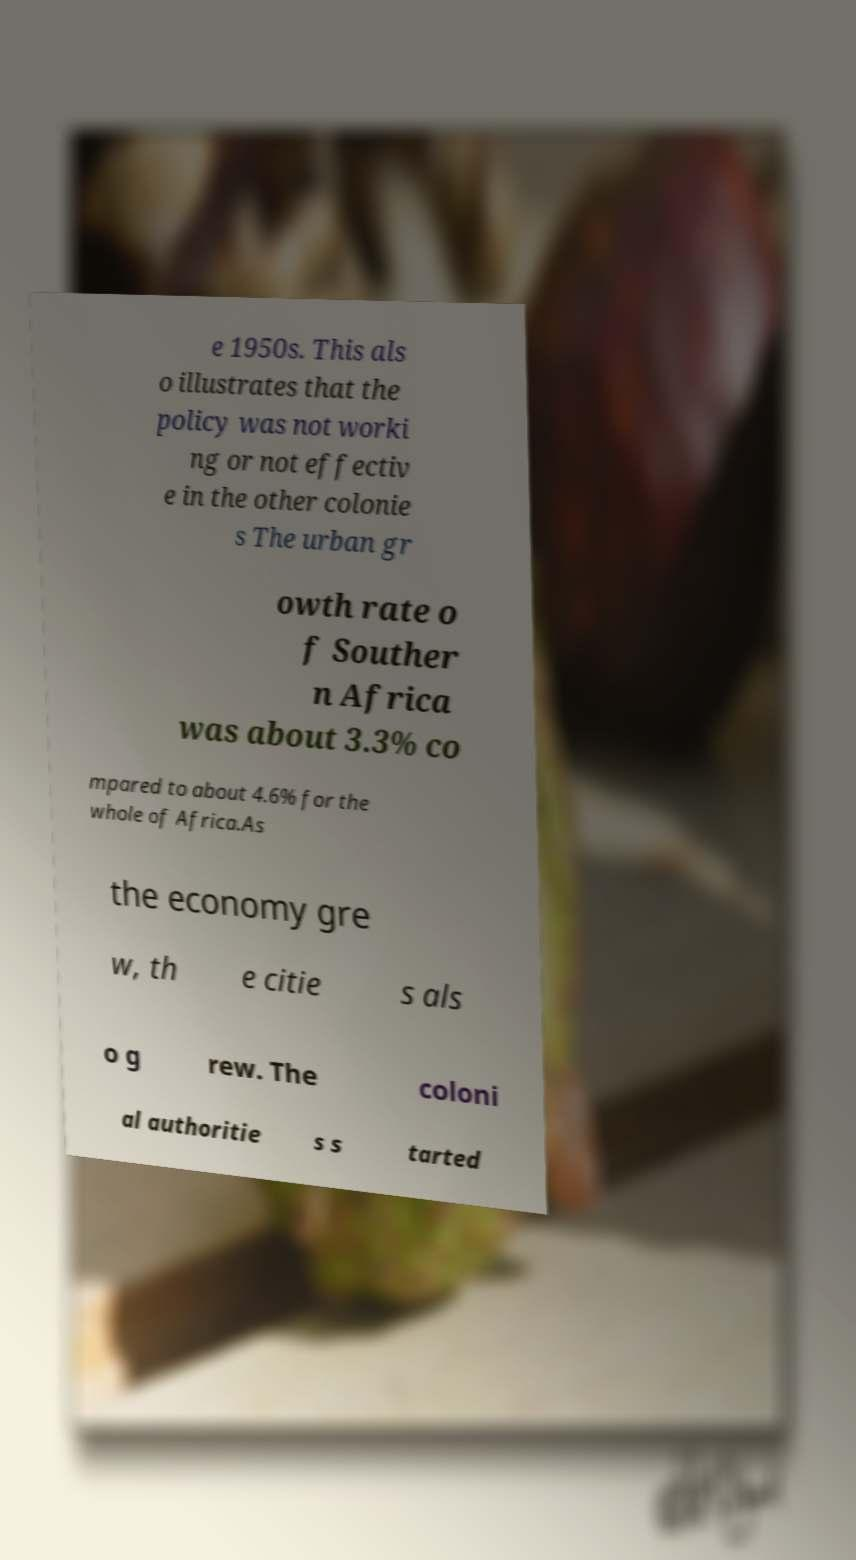What messages or text are displayed in this image? I need them in a readable, typed format. e 1950s. This als o illustrates that the policy was not worki ng or not effectiv e in the other colonie s The urban gr owth rate o f Souther n Africa was about 3.3% co mpared to about 4.6% for the whole of Africa.As the economy gre w, th e citie s als o g rew. The coloni al authoritie s s tarted 